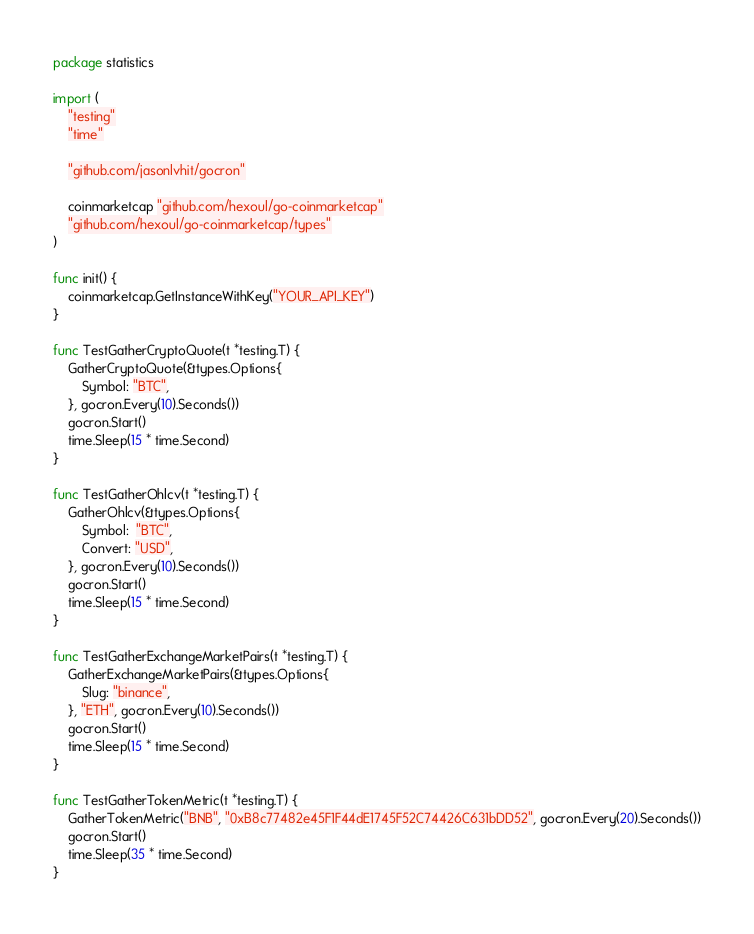Convert code to text. <code><loc_0><loc_0><loc_500><loc_500><_Go_>package statistics

import (
	"testing"
	"time"

	"github.com/jasonlvhit/gocron"

	coinmarketcap "github.com/hexoul/go-coinmarketcap"
	"github.com/hexoul/go-coinmarketcap/types"
)

func init() {
	coinmarketcap.GetInstanceWithKey("YOUR_API_KEY")
}

func TestGatherCryptoQuote(t *testing.T) {
	GatherCryptoQuote(&types.Options{
		Symbol: "BTC",
	}, gocron.Every(10).Seconds())
	gocron.Start()
	time.Sleep(15 * time.Second)
}

func TestGatherOhlcv(t *testing.T) {
	GatherOhlcv(&types.Options{
		Symbol:  "BTC",
		Convert: "USD",
	}, gocron.Every(10).Seconds())
	gocron.Start()
	time.Sleep(15 * time.Second)
}

func TestGatherExchangeMarketPairs(t *testing.T) {
	GatherExchangeMarketPairs(&types.Options{
		Slug: "binance",
	}, "ETH", gocron.Every(10).Seconds())
	gocron.Start()
	time.Sleep(15 * time.Second)
}

func TestGatherTokenMetric(t *testing.T) {
	GatherTokenMetric("BNB", "0xB8c77482e45F1F44dE1745F52C74426C631bDD52", gocron.Every(20).Seconds())
	gocron.Start()
	time.Sleep(35 * time.Second)
}
</code> 